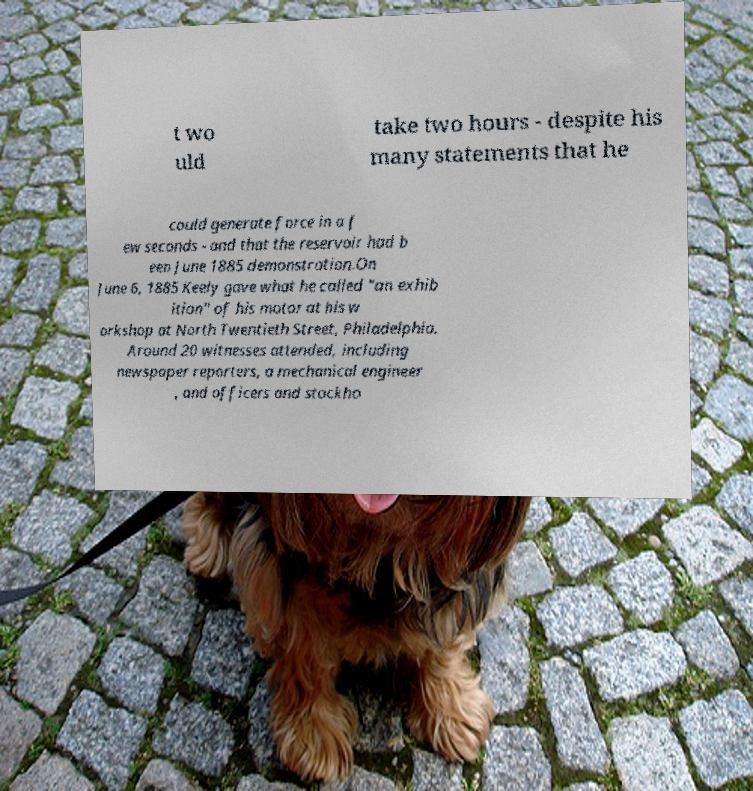Please identify and transcribe the text found in this image. t wo uld take two hours - despite his many statements that he could generate force in a f ew seconds - and that the reservoir had b een June 1885 demonstration.On June 6, 1885 Keely gave what he called "an exhib ition" of his motor at his w orkshop at North Twentieth Street, Philadelphia. Around 20 witnesses attended, including newspaper reporters, a mechanical engineer , and officers and stockho 